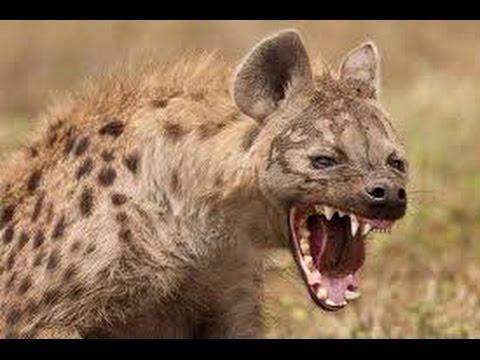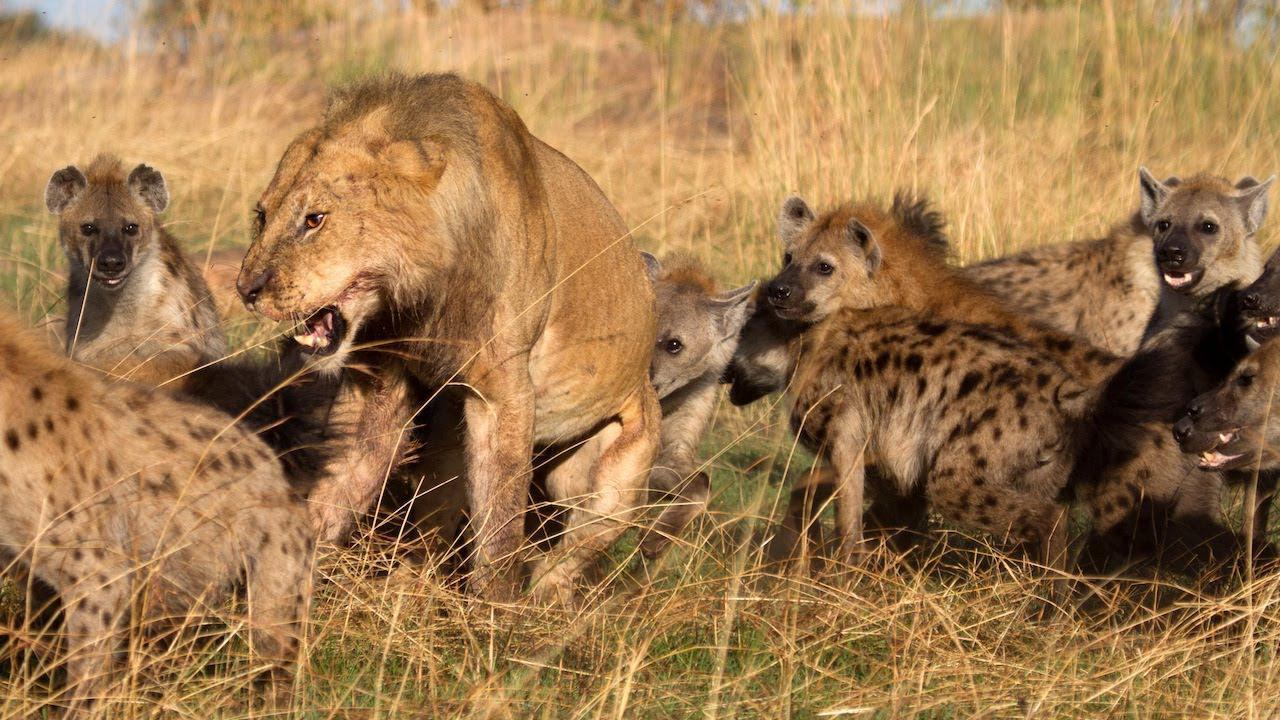The first image is the image on the left, the second image is the image on the right. For the images shown, is this caption "The lefthand image contains a single hyena, and the right image contains at least four hyena." true? Answer yes or no. Yes. The first image is the image on the left, the second image is the image on the right. Analyze the images presented: Is the assertion "There is a single hyena in the image on the left." valid? Answer yes or no. Yes. 